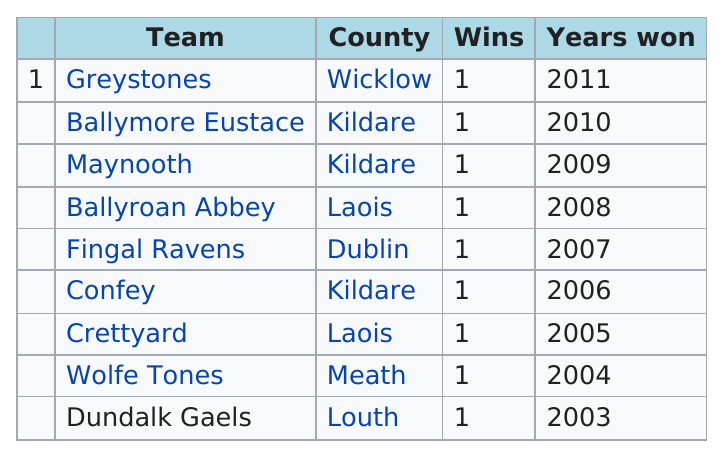Specify some key components in this picture. After Ballymore Eustace, Greystones won the match. I have a list of team wins from 1 to [number of teams], and I need to determine the number of wins for each team. Kildare county had the most number of wins out of all the counties. Confey has won 1 game. The Wolfe Tones won the previous game before Crettyard. 